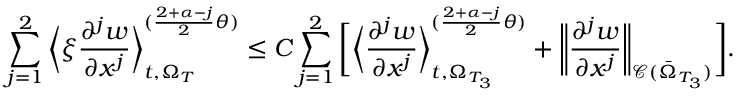Convert formula to latex. <formula><loc_0><loc_0><loc_500><loc_500>\sum _ { j = 1 } ^ { 2 } \left \langle \xi \frac { \partial ^ { j } w } { \partial x ^ { j } } \right \rangle _ { t , \Omega _ { T } } ^ { ( \frac { 2 + \alpha - j } { 2 } \theta ) } \leq C \sum _ { j = 1 } ^ { 2 } \left [ \left \langle \frac { \partial ^ { j } w } { \partial x ^ { j } } \right \rangle _ { t , \Omega _ { T _ { 3 } } } ^ { ( \frac { 2 + \alpha - j } { 2 } \theta ) } + \left \| \frac { \partial ^ { j } w } { \partial x ^ { j } } \right \| _ { \mathcal { C } ( \bar { \Omega } _ { T _ { 3 } } ) } \right ] .</formula> 